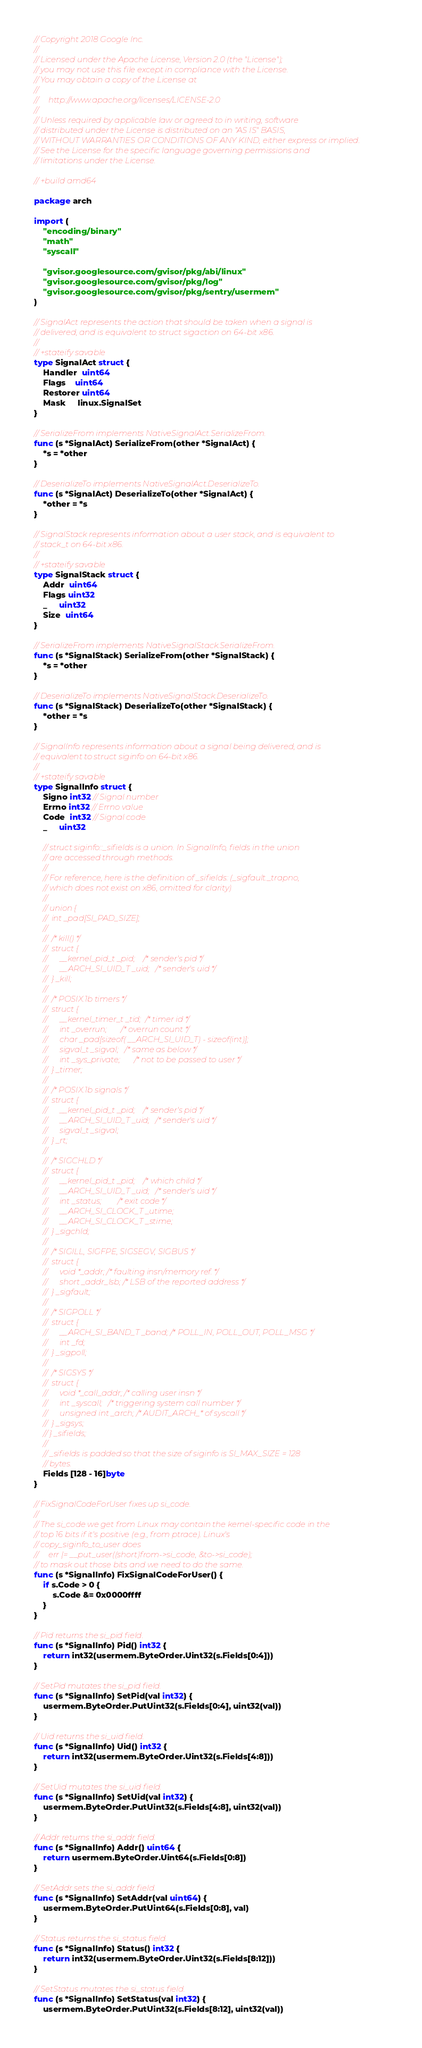Convert code to text. <code><loc_0><loc_0><loc_500><loc_500><_Go_>// Copyright 2018 Google Inc.
//
// Licensed under the Apache License, Version 2.0 (the "License");
// you may not use this file except in compliance with the License.
// You may obtain a copy of the License at
//
//     http://www.apache.org/licenses/LICENSE-2.0
//
// Unless required by applicable law or agreed to in writing, software
// distributed under the License is distributed on an "AS IS" BASIS,
// WITHOUT WARRANTIES OR CONDITIONS OF ANY KIND, either express or implied.
// See the License for the specific language governing permissions and
// limitations under the License.

// +build amd64

package arch

import (
	"encoding/binary"
	"math"
	"syscall"

	"gvisor.googlesource.com/gvisor/pkg/abi/linux"
	"gvisor.googlesource.com/gvisor/pkg/log"
	"gvisor.googlesource.com/gvisor/pkg/sentry/usermem"
)

// SignalAct represents the action that should be taken when a signal is
// delivered, and is equivalent to struct sigaction on 64-bit x86.
//
// +stateify savable
type SignalAct struct {
	Handler  uint64
	Flags    uint64
	Restorer uint64
	Mask     linux.SignalSet
}

// SerializeFrom implements NativeSignalAct.SerializeFrom.
func (s *SignalAct) SerializeFrom(other *SignalAct) {
	*s = *other
}

// DeserializeTo implements NativeSignalAct.DeserializeTo.
func (s *SignalAct) DeserializeTo(other *SignalAct) {
	*other = *s
}

// SignalStack represents information about a user stack, and is equivalent to
// stack_t on 64-bit x86.
//
// +stateify savable
type SignalStack struct {
	Addr  uint64
	Flags uint32
	_     uint32
	Size  uint64
}

// SerializeFrom implements NativeSignalStack.SerializeFrom.
func (s *SignalStack) SerializeFrom(other *SignalStack) {
	*s = *other
}

// DeserializeTo implements NativeSignalStack.DeserializeTo.
func (s *SignalStack) DeserializeTo(other *SignalStack) {
	*other = *s
}

// SignalInfo represents information about a signal being delivered, and is
// equivalent to struct siginfo on 64-bit x86.
//
// +stateify savable
type SignalInfo struct {
	Signo int32 // Signal number
	Errno int32 // Errno value
	Code  int32 // Signal code
	_     uint32

	// struct siginfo::_sifields is a union. In SignalInfo, fields in the union
	// are accessed through methods.
	//
	// For reference, here is the definition of _sifields: (_sigfault._trapno,
	// which does not exist on x86, omitted for clarity)
	//
	// union {
	// 	int _pad[SI_PAD_SIZE];
	//
	// 	/* kill() */
	// 	struct {
	// 		__kernel_pid_t _pid;	/* sender's pid */
	// 		__ARCH_SI_UID_T _uid;	/* sender's uid */
	// 	} _kill;
	//
	// 	/* POSIX.1b timers */
	// 	struct {
	// 		__kernel_timer_t _tid;	/* timer id */
	// 		int _overrun;		/* overrun count */
	// 		char _pad[sizeof( __ARCH_SI_UID_T) - sizeof(int)];
	// 		sigval_t _sigval;	/* same as below */
	// 		int _sys_private;       /* not to be passed to user */
	// 	} _timer;
	//
	// 	/* POSIX.1b signals */
	// 	struct {
	// 		__kernel_pid_t _pid;	/* sender's pid */
	// 		__ARCH_SI_UID_T _uid;	/* sender's uid */
	// 		sigval_t _sigval;
	// 	} _rt;
	//
	// 	/* SIGCHLD */
	// 	struct {
	// 		__kernel_pid_t _pid;	/* which child */
	// 		__ARCH_SI_UID_T _uid;	/* sender's uid */
	// 		int _status;		/* exit code */
	// 		__ARCH_SI_CLOCK_T _utime;
	// 		__ARCH_SI_CLOCK_T _stime;
	// 	} _sigchld;
	//
	// 	/* SIGILL, SIGFPE, SIGSEGV, SIGBUS */
	// 	struct {
	// 		void *_addr; /* faulting insn/memory ref. */
	// 		short _addr_lsb; /* LSB of the reported address */
	// 	} _sigfault;
	//
	// 	/* SIGPOLL */
	// 	struct {
	// 		__ARCH_SI_BAND_T _band;	/* POLL_IN, POLL_OUT, POLL_MSG */
	// 		int _fd;
	// 	} _sigpoll;
	//
	// 	/* SIGSYS */
	// 	struct {
	// 		void *_call_addr; /* calling user insn */
	// 		int _syscall;	/* triggering system call number */
	// 		unsigned int _arch;	/* AUDIT_ARCH_* of syscall */
	// 	} _sigsys;
	// } _sifields;
	//
	// _sifields is padded so that the size of siginfo is SI_MAX_SIZE = 128
	// bytes.
	Fields [128 - 16]byte
}

// FixSignalCodeForUser fixes up si_code.
//
// The si_code we get from Linux may contain the kernel-specific code in the
// top 16 bits if it's positive (e.g., from ptrace). Linux's
// copy_siginfo_to_user does
//     err |= __put_user((short)from->si_code, &to->si_code);
// to mask out those bits and we need to do the same.
func (s *SignalInfo) FixSignalCodeForUser() {
	if s.Code > 0 {
		s.Code &= 0x0000ffff
	}
}

// Pid returns the si_pid field.
func (s *SignalInfo) Pid() int32 {
	return int32(usermem.ByteOrder.Uint32(s.Fields[0:4]))
}

// SetPid mutates the si_pid field.
func (s *SignalInfo) SetPid(val int32) {
	usermem.ByteOrder.PutUint32(s.Fields[0:4], uint32(val))
}

// Uid returns the si_uid field.
func (s *SignalInfo) Uid() int32 {
	return int32(usermem.ByteOrder.Uint32(s.Fields[4:8]))
}

// SetUid mutates the si_uid field.
func (s *SignalInfo) SetUid(val int32) {
	usermem.ByteOrder.PutUint32(s.Fields[4:8], uint32(val))
}

// Addr returns the si_addr field.
func (s *SignalInfo) Addr() uint64 {
	return usermem.ByteOrder.Uint64(s.Fields[0:8])
}

// SetAddr sets the si_addr field.
func (s *SignalInfo) SetAddr(val uint64) {
	usermem.ByteOrder.PutUint64(s.Fields[0:8], val)
}

// Status returns the si_status field.
func (s *SignalInfo) Status() int32 {
	return int32(usermem.ByteOrder.Uint32(s.Fields[8:12]))
}

// SetStatus mutates the si_status field.
func (s *SignalInfo) SetStatus(val int32) {
	usermem.ByteOrder.PutUint32(s.Fields[8:12], uint32(val))</code> 